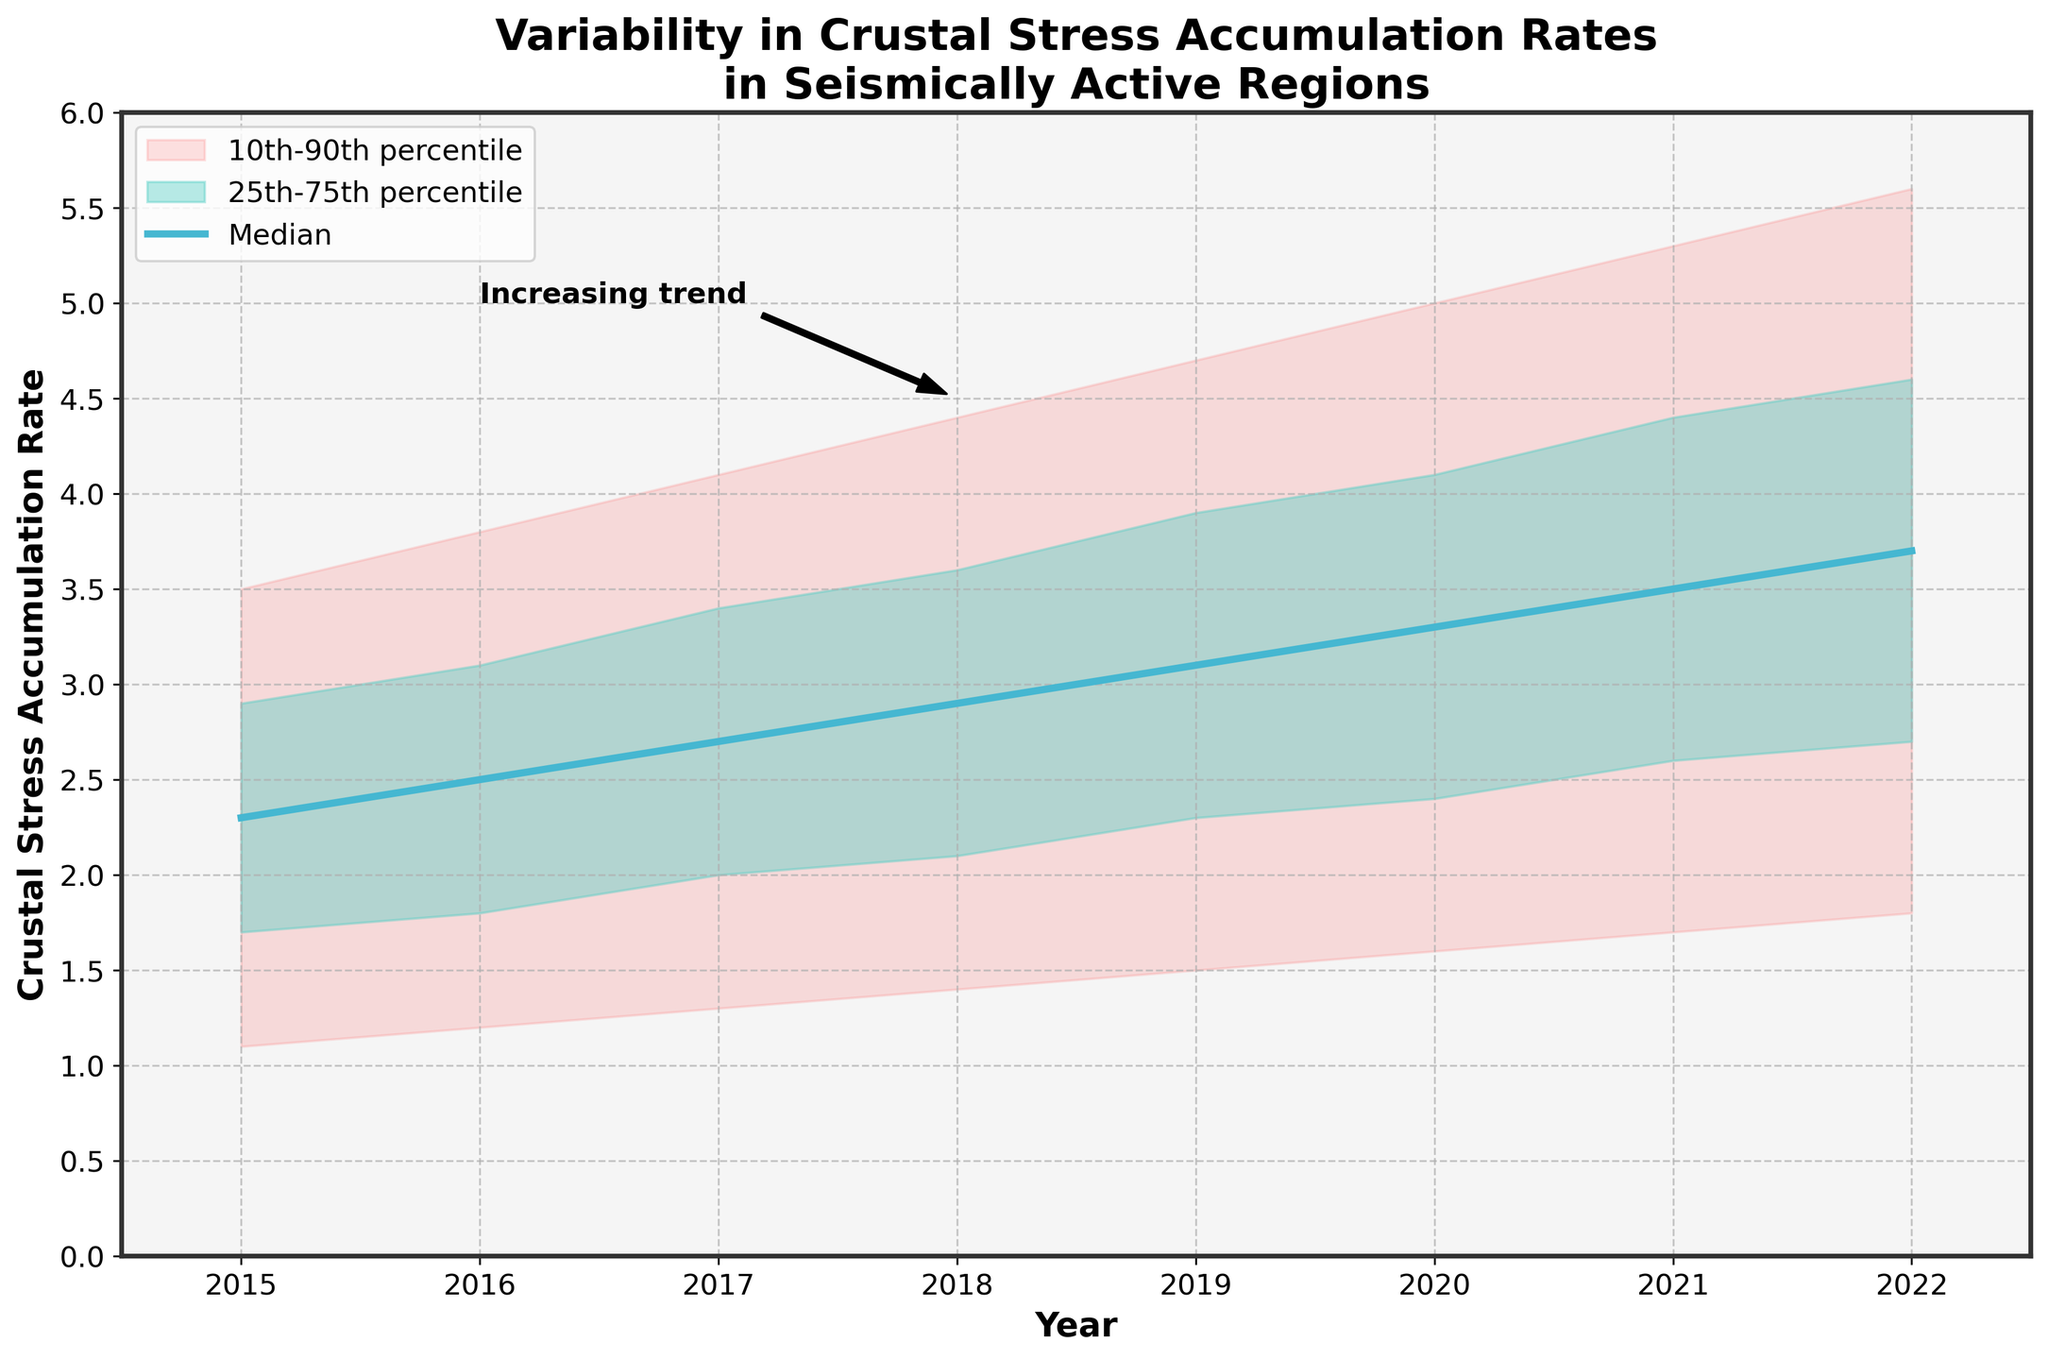What is the title of the chart? The title is prominently displayed at the top of the chart. It reads, "Variability in Crustal Stress Accumulation Rates in Seismically Active Regions."
Answer: Variability in Crustal Stress Accumulation Rates in Seismically Active Regions What is the median crustal stress accumulation rate in 2017? Locate the year 2017 on the x-axis and follow it up to the median line, and read the corresponding value on the y-axis. It shows approximately 2.7.
Answer: 2.7 How does the median crustal stress accumulation rate change from 2015 to 2022? Note the median value for each year from 2015 to 2022 and track the trend. The median rate increases from 2.3 in 2015 to 3.7 in 2022, showing a steady upward trend.
Answer: It increases Which range represents the 10th to 90th percentile in the chart? The 10th to 90th percentile range is represented by the shaded area with a lighter color, which encompasses a broader range on the y-axis for each year.
Answer: The lightly shaded area between the lower 10th and upper 90th percentile lines What is the widest range of crustal stress accumulation rates observed in any given year? To find this, observe the maximum spread in the fan chart for any year by examining the distance between the 10th percentile and the 90th percentile lines. The largest spread appears in 2022, with a range from 1.8 to 5.6 which equals a spread of 3.8.
Answer: 3.8 What is the difference between the upper 75th and lower 25th percentiles in 2020? Locate the upper 75th percentile and lower 25th percentile values for 2020. The upper 75th is 4.1 and the lower 25th is 2.4. Subtract the lower 25th from the upper 75th, i.e., 4.1 - 2.4 = 1.7.
Answer: 1.7 Is the crustal stress accumulation rate generally increasing, decreasing, or stable over the years? Observe the general trend of the median line from 2015 to 2022. The line shows a clear upward trend indicating an increase.
Answer: Increasing In which year did the median crustal stress accumulation rate first reach 3.0? Trace the median line and identify the first instance where it reaches or exceeds 3.0. This occurs in the year 2019 with a median rate of 3.1.
Answer: 2019 By how much did the median crustal stress accumulation rate increase from 2016 to 2020? Look at the median values for 2016 (2.5) and 2020 (3.3). Subtract the value in 2016 from the value in 2020, i.e., 3.3 - 2.5 = 0.8.
Answer: 0.8 Which year shows the smallest range between the lower 10th and upper 90th percentiles? Examine the fan chart and look for the year with the narrowest spread between the lower 10th and upper 90th percentile lines. The smallest range appears to be in 2015, where it spans from 1.1 to 3.5, equaling a range of 2.4.
Answer: 2015 